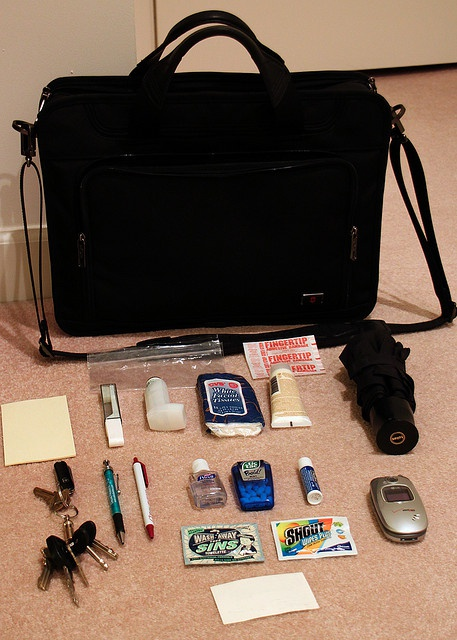Describe the objects in this image and their specific colors. I can see handbag in tan, black, and gray tones, umbrella in tan, black, maroon, and gray tones, cell phone in tan, gray, maroon, and darkgray tones, and toothbrush in tan, ivory, darkgray, and beige tones in this image. 